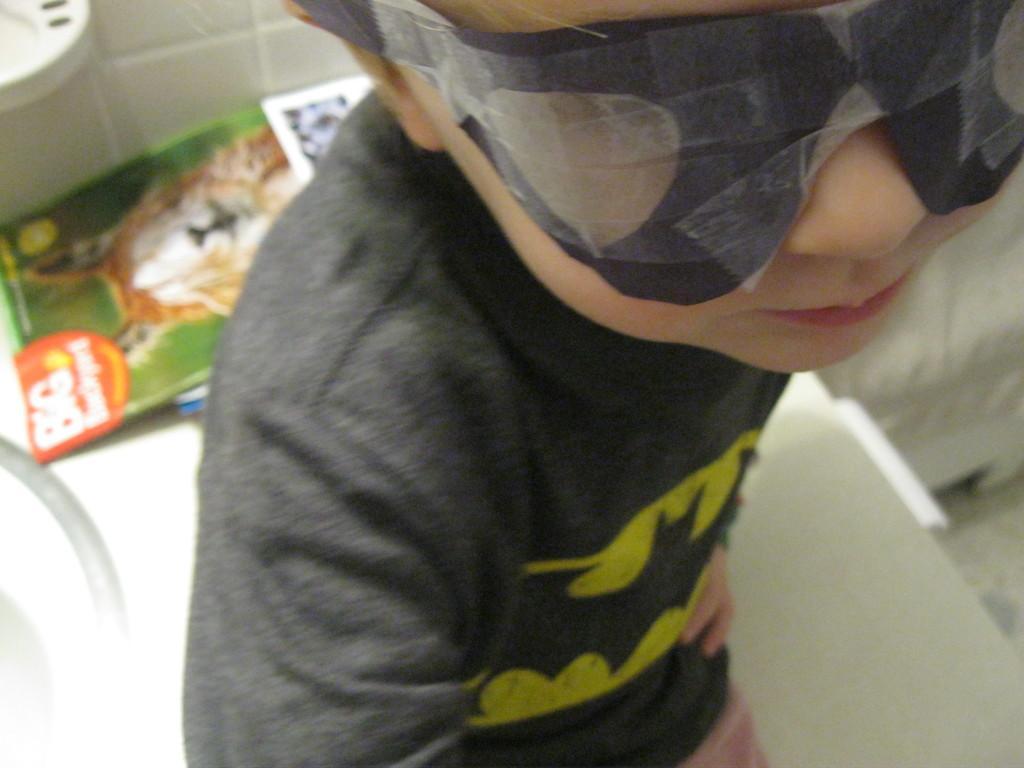Can you describe this image briefly? In this image I can see a person is wearing black color dress and he is wearing a mask. Back I can few books and white surface. 